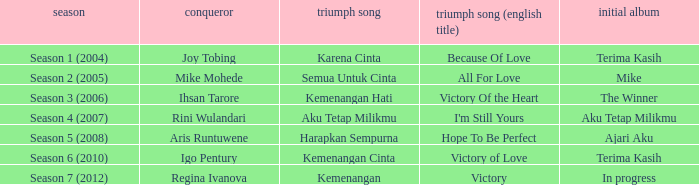Which album debuted in season 2 (2005)? Mike. 